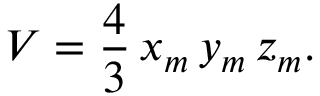Convert formula to latex. <formula><loc_0><loc_0><loc_500><loc_500>V = { \frac { 4 } { 3 } } \, x _ { m } \, y _ { m } \, z _ { m } .</formula> 